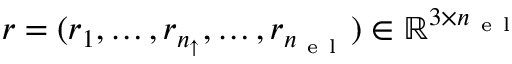<formula> <loc_0><loc_0><loc_500><loc_500>{ r } = ( { r } _ { 1 } , \dots , { r } _ { n _ { \uparrow } } , \dots , { r } _ { { n _ { e l } } } ) \in \mathbb { R } ^ { 3 \times { n _ { e l } } }</formula> 